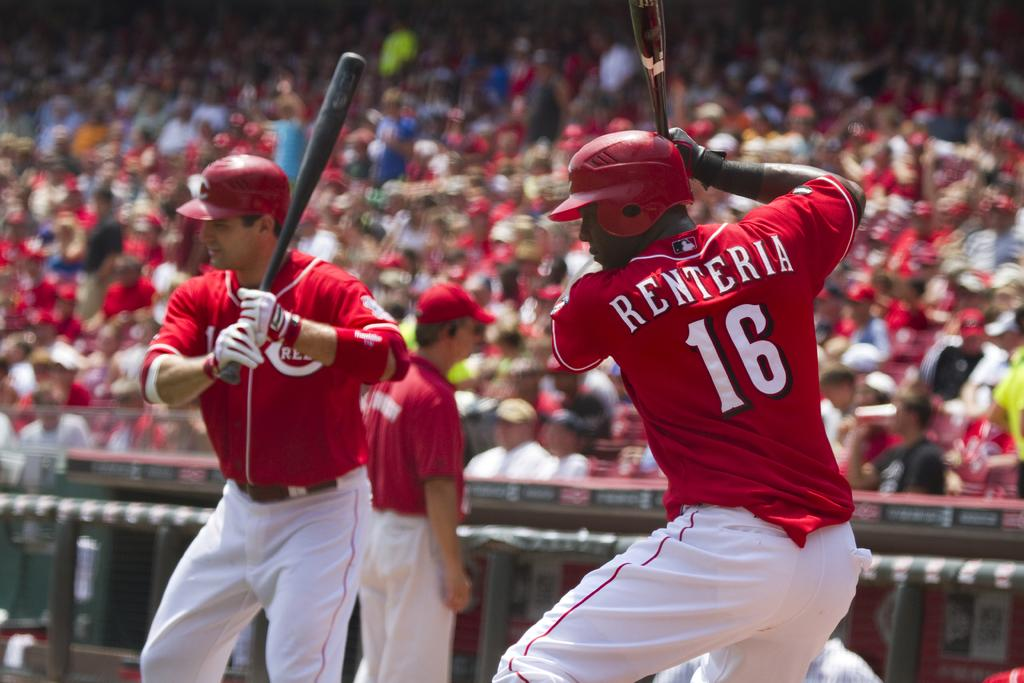<image>
Share a concise interpretation of the image provided. The batter on the right side shirt says Renteria 16 on the back. 